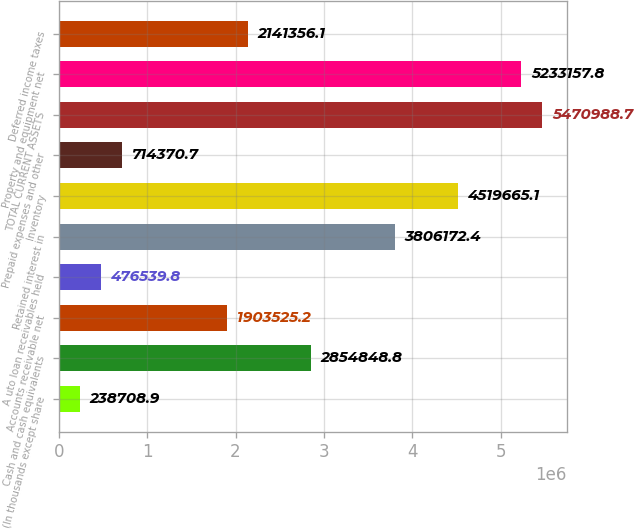Convert chart. <chart><loc_0><loc_0><loc_500><loc_500><bar_chart><fcel>(In thousands except share<fcel>Cash and cash equivalents<fcel>Accounts receivable net<fcel>A uto loan receivables held<fcel>Retained interest in<fcel>Inventory<fcel>Prepaid expenses and other<fcel>TOTAL CURRENT ASSETS<fcel>Property and equipment net<fcel>Deferred income taxes<nl><fcel>238709<fcel>2.85485e+06<fcel>1.90353e+06<fcel>476540<fcel>3.80617e+06<fcel>4.51967e+06<fcel>714371<fcel>5.47099e+06<fcel>5.23316e+06<fcel>2.14136e+06<nl></chart> 